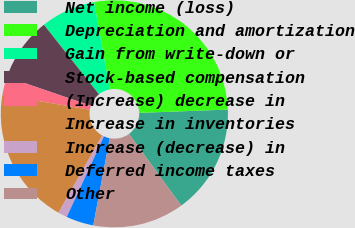Convert chart to OTSL. <chart><loc_0><loc_0><loc_500><loc_500><pie_chart><fcel>Net income (loss)<fcel>Depreciation and amortization<fcel>Gain from write-down or<fcel>Stock-based compensation<fcel>(Increase) decrease in<fcel>Increase in inventories<fcel>Increase (decrease) in<fcel>Deferred income taxes<fcel>Other<nl><fcel>15.58%<fcel>27.27%<fcel>7.79%<fcel>9.09%<fcel>2.6%<fcel>19.48%<fcel>1.3%<fcel>3.9%<fcel>12.99%<nl></chart> 